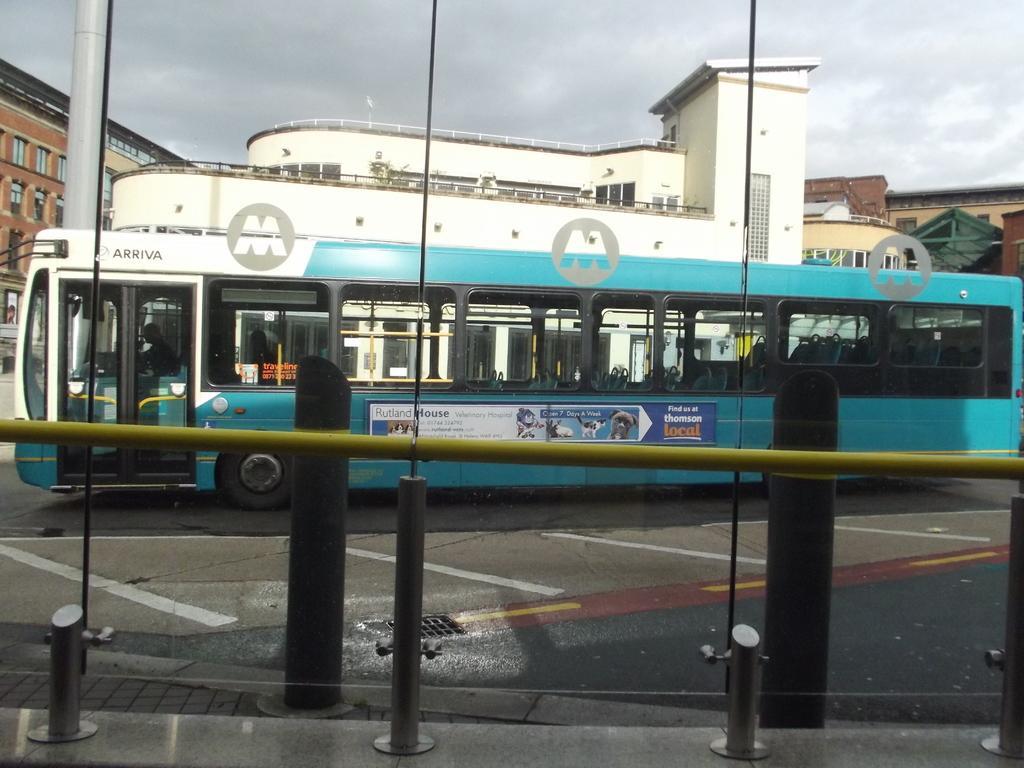Could you give a brief overview of what you see in this image? In this image, we can see few people are riding a bus on the road. At the bottom, we can see few rods, walkway. Background we can see buildings, walls, railings and windows. Top of the image, there is a sky. On the left side of the image, we can see pillar. 